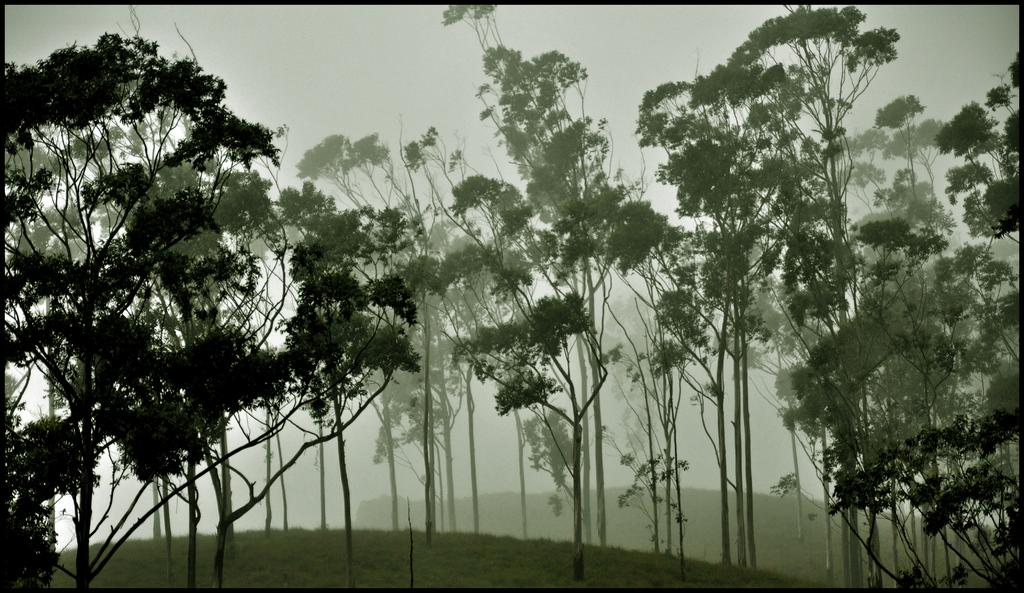What type of vegetation can be seen in the image? There are trees in the image. Where is the zinc faucet located in the image? There is no faucet or zinc present in the image; it only features trees. What type of cart can be seen carrying the trees in the image? There is no cart present in the image; it only features trees. 